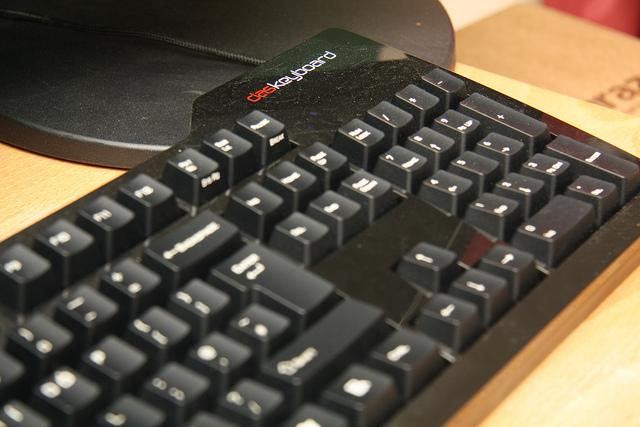What brand of keyboard is this?
Be succinct. Das keyboard. Is this an extended keyboard?
Keep it brief. Yes. Is this keyboard wireless?
Be succinct. No. 